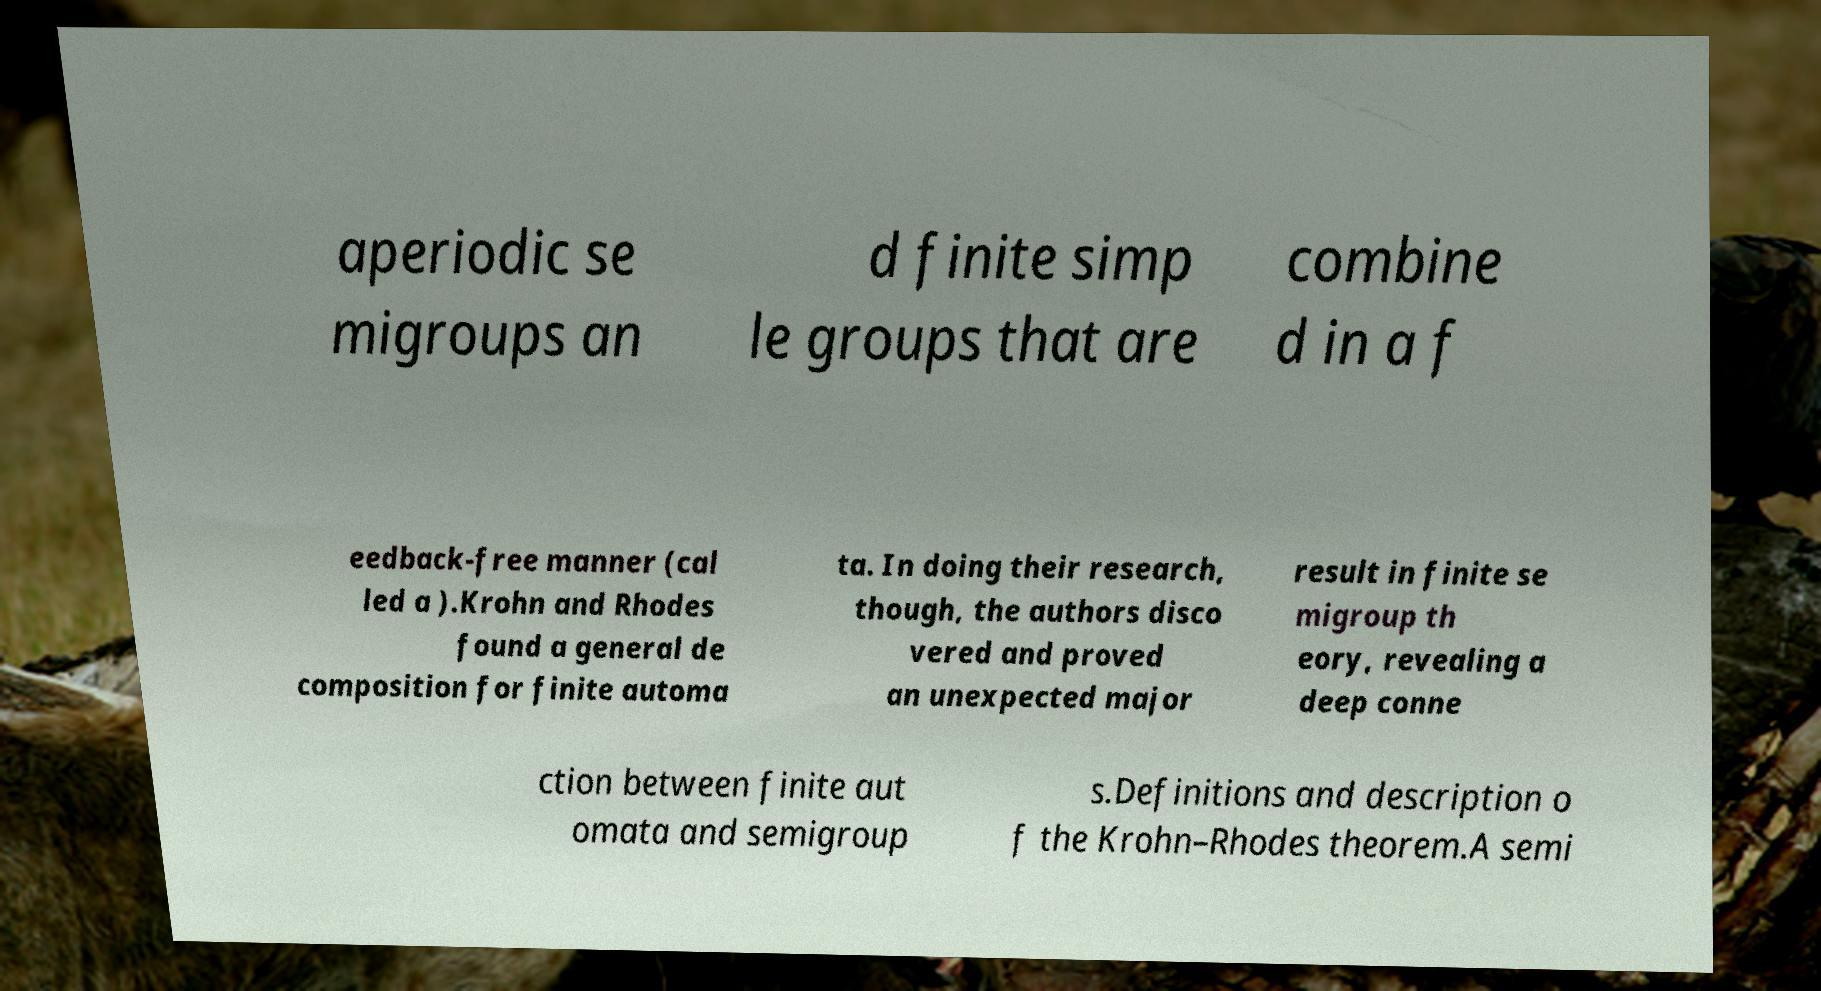I need the written content from this picture converted into text. Can you do that? aperiodic se migroups an d finite simp le groups that are combine d in a f eedback-free manner (cal led a ).Krohn and Rhodes found a general de composition for finite automa ta. In doing their research, though, the authors disco vered and proved an unexpected major result in finite se migroup th eory, revealing a deep conne ction between finite aut omata and semigroup s.Definitions and description o f the Krohn–Rhodes theorem.A semi 